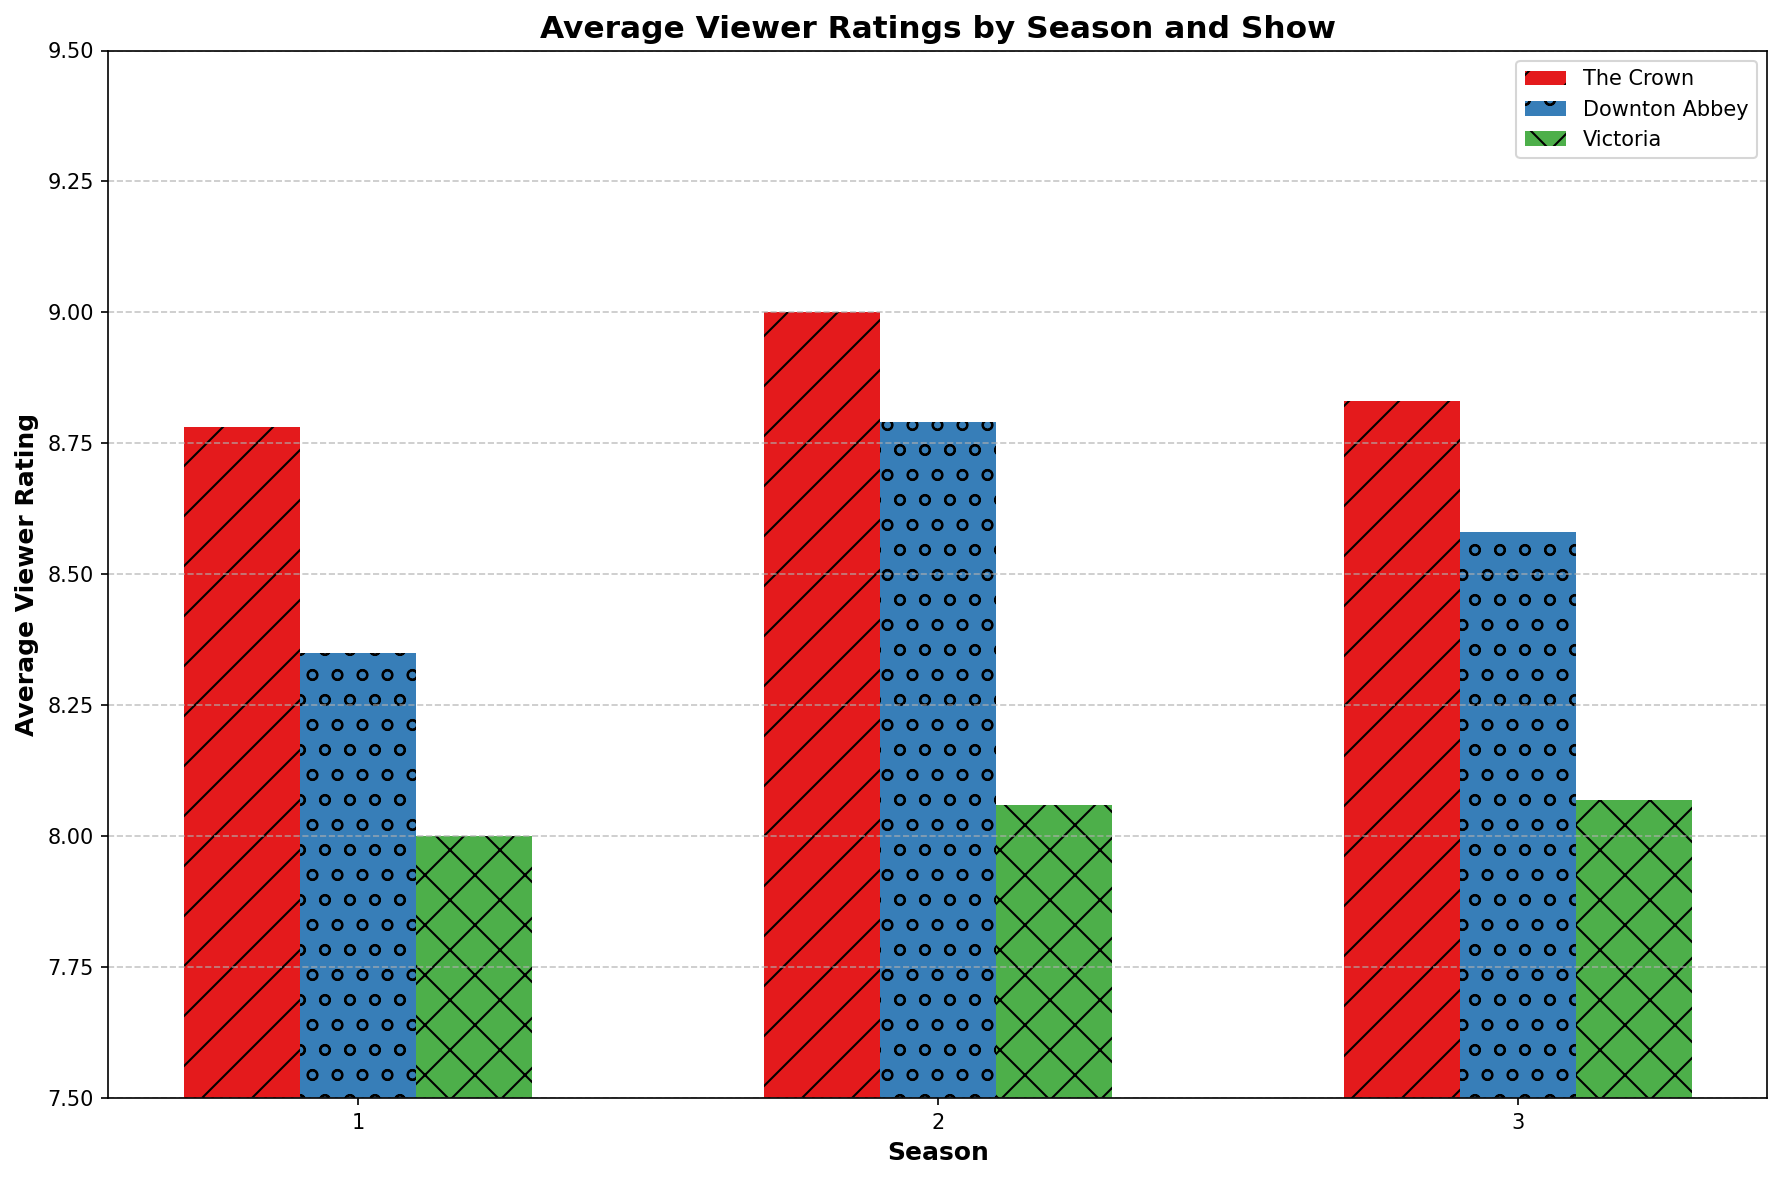Which show has the highest average viewer rating in Season 2? To find this, look for the highest bar in the Season 2 group. The colors associated with the shows are red for The Crown, blue for Downton Abbey, and green for Victoria. The tallest bar belongs to The Crown.
Answer: The Crown How does the average viewer rating of Downton Abbey in Season 1 compare to that in Season 3? Compare the height of the blue bars for Downton Abbey in Seasons 1 and 3. In Season 1, the average rating is lower compared to Season 3.
Answer: Lower in Season 1 What's the difference in average viewer ratings between the highest and lowest-rated shows in Season 1? Identify the tallest and shortest bars in the Season 1 group. The tallest is for The Crown (red) and the shortest is for Victoria (green). Calculate the difference between the average ratings.
Answer: 1.0 Which season had the lowest average viewer rating for Victoria? Look at the height of the green bars (Victoria) across all seasons. The shortest green bar indicates the season with the lowest rating, which is in Season 1.
Answer: Season 1 What is the pattern used for the bars representing The Crown? The pattern for The Crown is distinguishable by its visual attribute. The red bars have a '/' pattern.
Answer: Slash pattern Between The Crown and Victoria, which show had a higher average viewer rating in Season 3? Compare the heights of the red and green bars in Season 3. The red bars (The Crown) are taller than the green bars (Victoria).
Answer: The Crown What is the combined average viewer rating of all shows in Season 1? Calculate the average ratings for The Crown, Downton Abbey, and Victoria in Season 1, then add them together. For Season 1: The Crown = 8.75, Downton Abbey = 8.31, and Victoria = 8.0. Summing these gives 8.75 + 8.31 + 8.0.
Answer: 25.06 In which season did both The Crown and Downton Abbey have their highest average viewer ratings? Check the bar height for both The Crown (red) and Downton Abbey (blue) across all seasons. Both shows have their highest ratings in Season 2, where the bars are tallest.
Answer: Season 2 